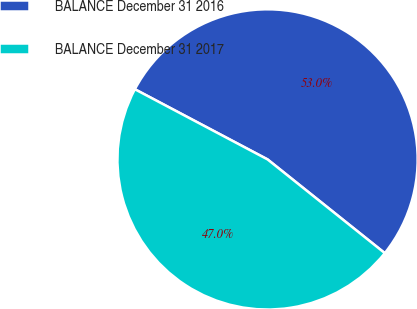Convert chart. <chart><loc_0><loc_0><loc_500><loc_500><pie_chart><fcel>BALANCE December 31 2016<fcel>BALANCE December 31 2017<nl><fcel>52.99%<fcel>47.01%<nl></chart> 